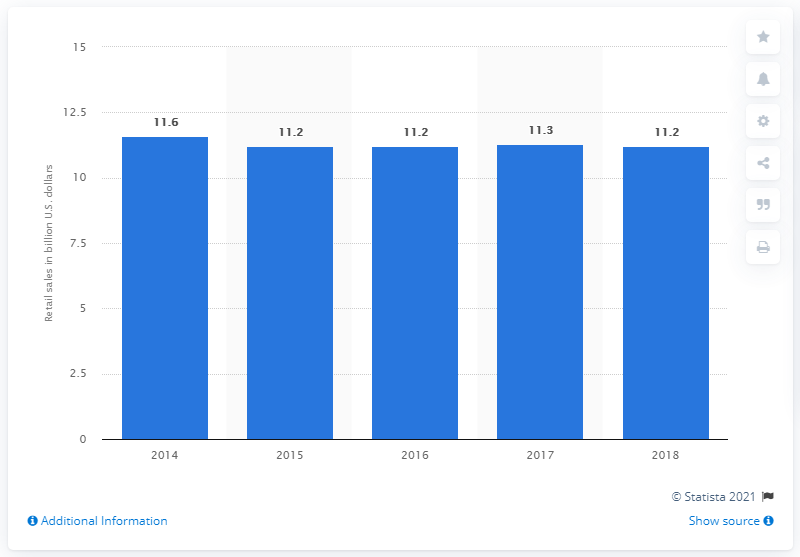Highlight a few significant elements in this photo. In 2018, the retail sales of chocolate in China totaled 11.2 billion U.S. dollars. 